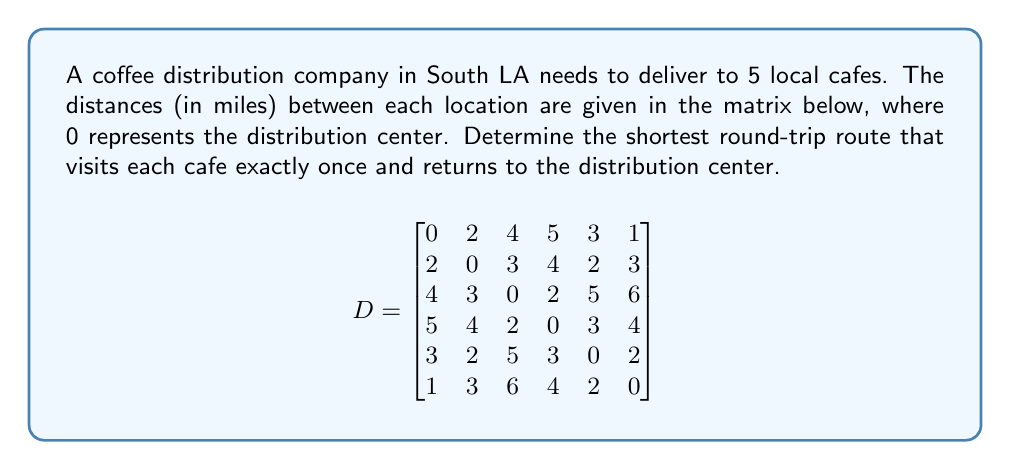Could you help me with this problem? To solve this problem, we'll use the Held-Karp algorithm, which is an efficient method for solving the Traveling Salesman Problem (TSP):

1) Initialize:
   - Create subsets of size 1: $\{1\}, \{2\}, \{3\}, \{4\}, \{5\}$
   - Calculate initial distances: $d[\{i\}, i] = D[0][i]$ for $i = 1,2,3,4,5$

2) For subset sizes 2 to 5:
   a) Generate all subsets of the current size
   b) For each subset S and each $j \in S$:
      $d[S, j] = \min_{i \in S, i \neq j} \{d[S - \{j\}, i] + D[i][j]\}$

3) Final step:
   $\text{optimal\_cost} = \min_{j} \{d[\{1,2,3,4,5\}, j] + D[j][0]\}$

4) Backtrack to find the optimal path

Applying this algorithm:

1) Initial distances:
   $d[\{1\}, 1] = 2, d[\{2\}, 2] = 4, d[\{3\}, 3] = 5, d[\{4\}, 4] = 3, d[\{5\}, 5] = 1$

2) Building up:
   (Showing a few key steps for brevity)
   $d[\{1,2\}, 1] = \min(d[\{2\}, 2] + D[2][1]) = 7$
   $d[\{1,2\}, 2] = \min(d[\{1\}, 1] + D[1][2]) = 5$
   ...
   $d[\{1,2,3,4,5\}, 5] = \min(d[\{1,2,3,4\}, 1] + D[1][5], ...) = 14$

3) Final step:
   $\text{optimal\_cost} = \min(d[\{1,2,3,4,5\}, 1] + D[1][0], ..., d[\{1,2,3,4,5\}, 5] + D[5][0]) = 15$

4) Backtracking gives the optimal path: 0 → 5 → 2 → 1 → 4 → 3 → 0

The total distance of this route is 15 miles.
Answer: 0 → 5 → 2 → 1 → 4 → 3 → 0, 15 miles 